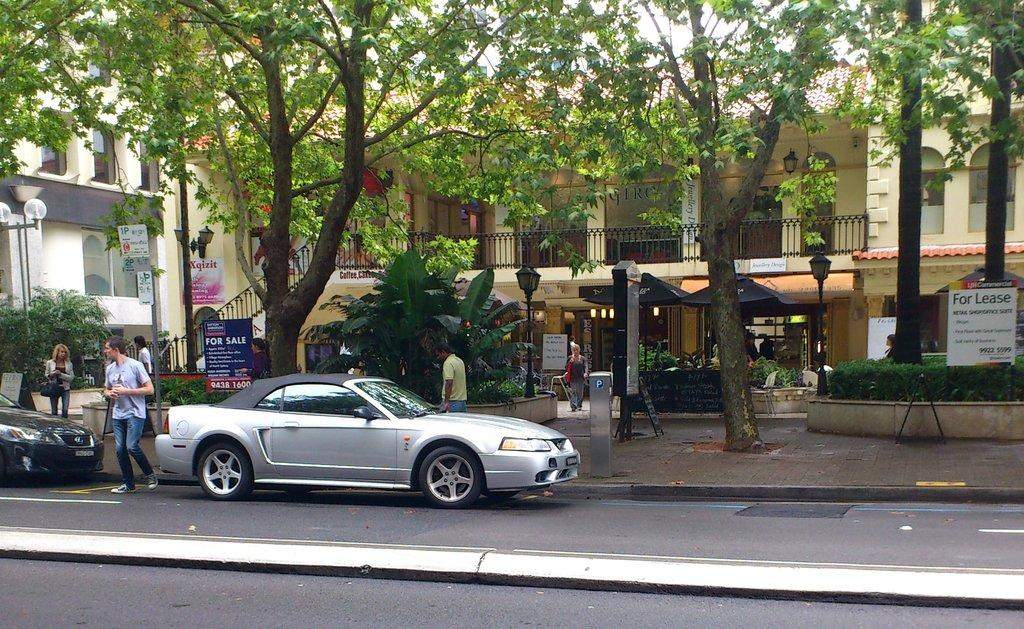What can be seen on the road in the image? There are cars on the road in the image. Who or what else is present in the image? There are people in the image. What can be seen in the background of the image? There are tents, buildings, poles, boards, trees, and the sky visible in the background of the image. Are there any natural elements in the image? Yes, there are trees in the background of the image. What might be used to separate different areas in the image? There are hedges in the image. What type of stem can be seen growing from the cars in the image? There are no stems growing from the cars in the image. How many wheels can be seen on the people in the image? The people in the image do not have wheels; they have legs for walking. 